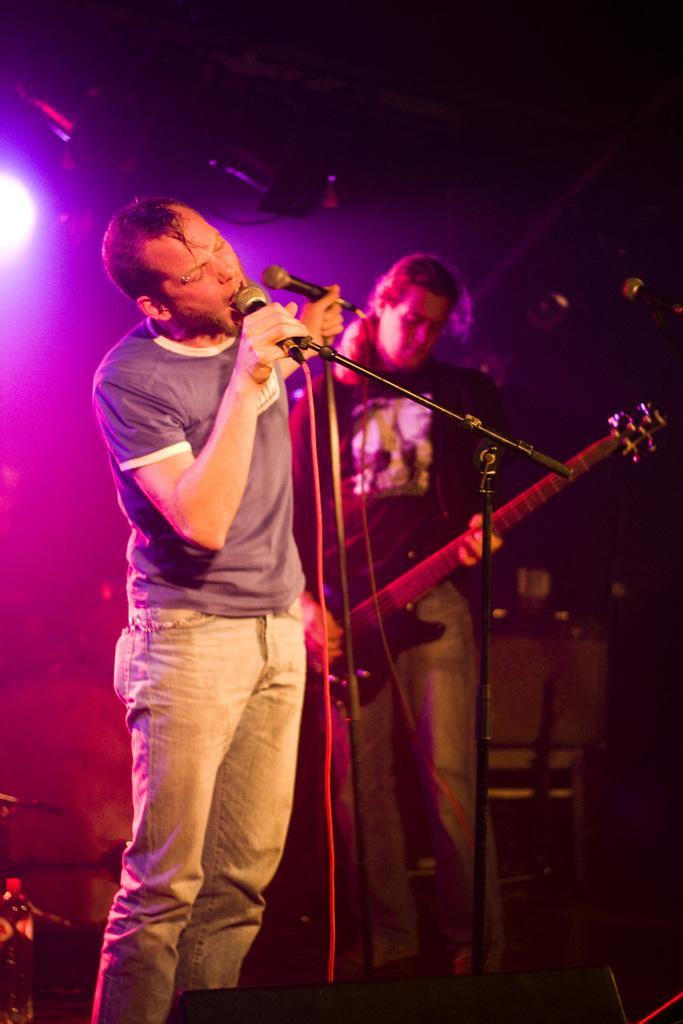Could you give a brief overview of what you see in this image? There is a man who is singing on the mike. And he is playing guitar. 